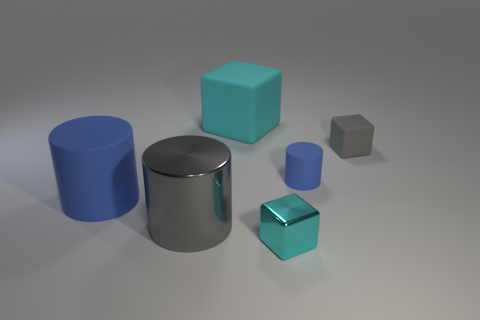Add 3 small cyan cubes. How many objects exist? 9 Subtract all things. Subtract all gray metal cubes. How many objects are left? 0 Add 4 blue matte cylinders. How many blue matte cylinders are left? 6 Add 3 large gray objects. How many large gray objects exist? 4 Subtract 0 blue spheres. How many objects are left? 6 